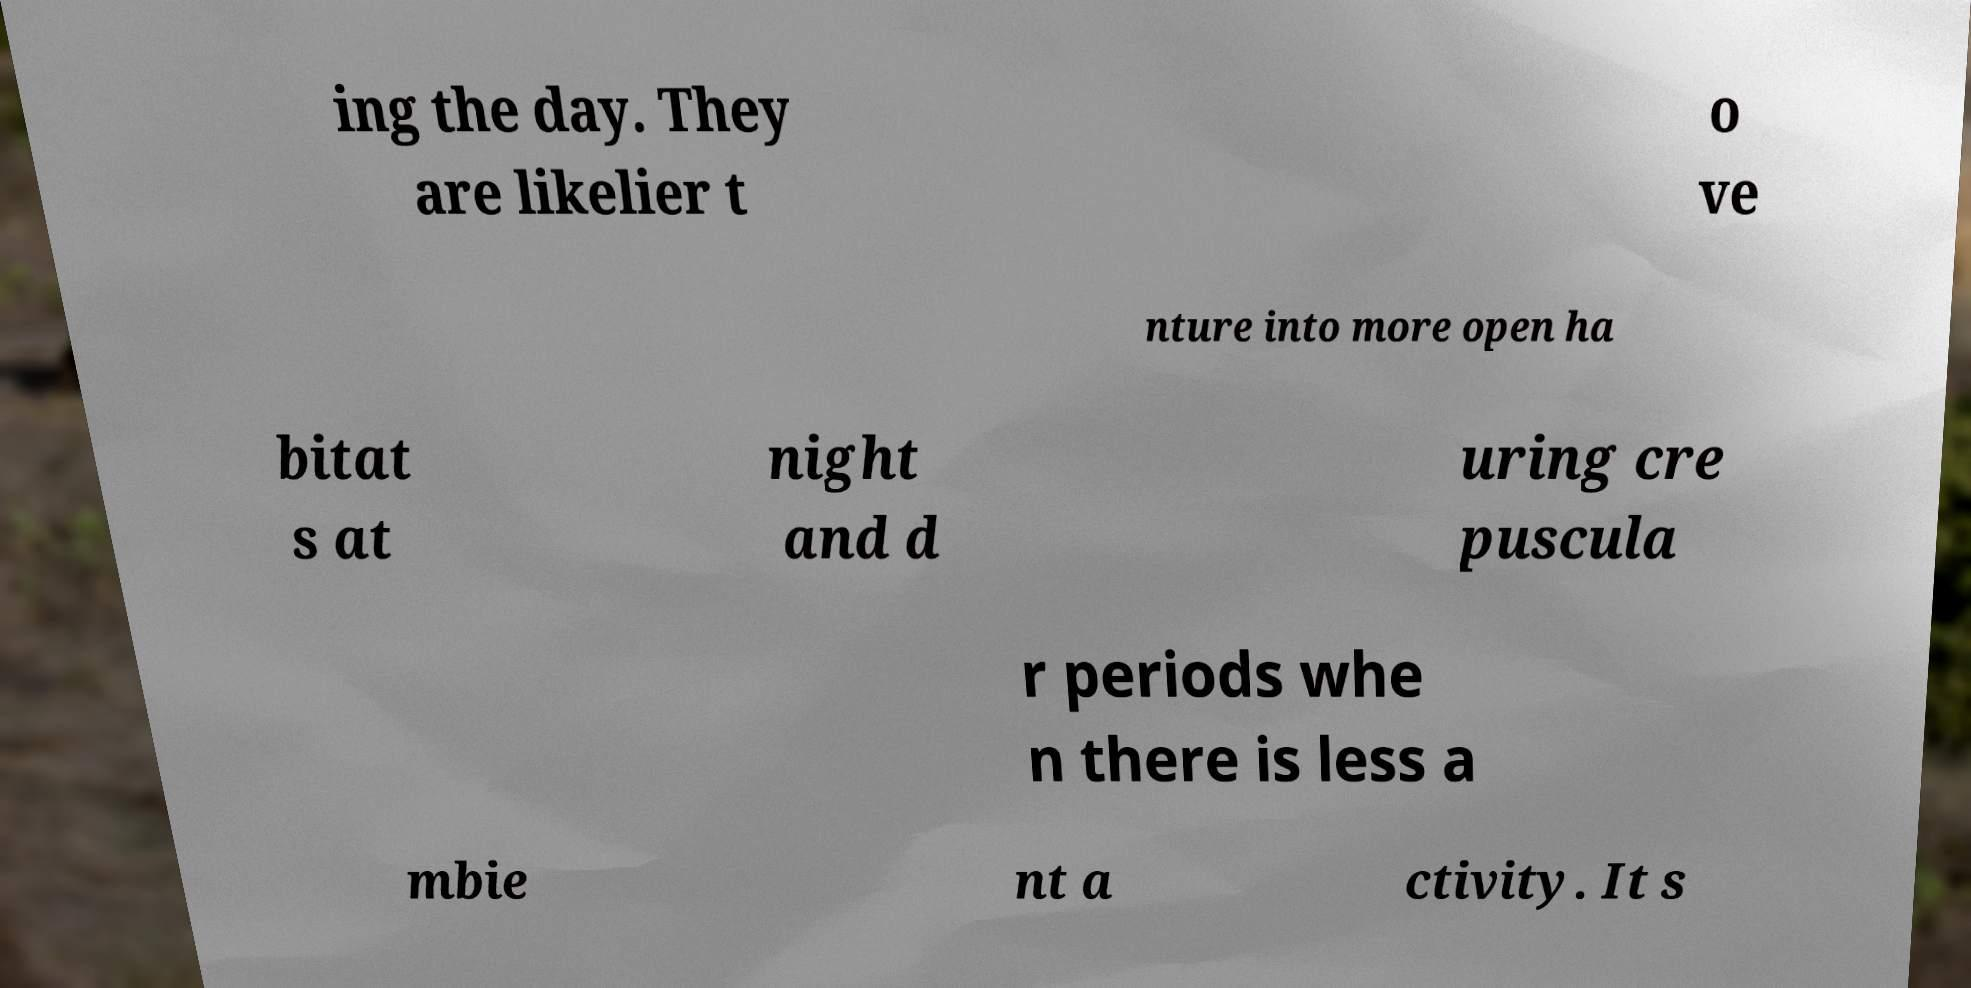Can you read and provide the text displayed in the image?This photo seems to have some interesting text. Can you extract and type it out for me? ing the day. They are likelier t o ve nture into more open ha bitat s at night and d uring cre puscula r periods whe n there is less a mbie nt a ctivity. It s 